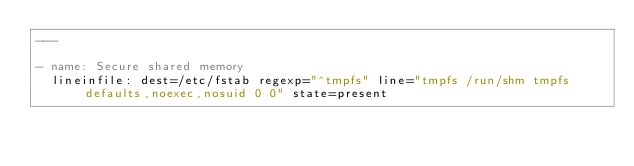<code> <loc_0><loc_0><loc_500><loc_500><_YAML_>---

- name: Secure shared memory
  lineinfile: dest=/etc/fstab regexp="^tmpfs" line="tmpfs /run/shm tmpfs defaults,noexec,nosuid 0 0" state=present
</code> 